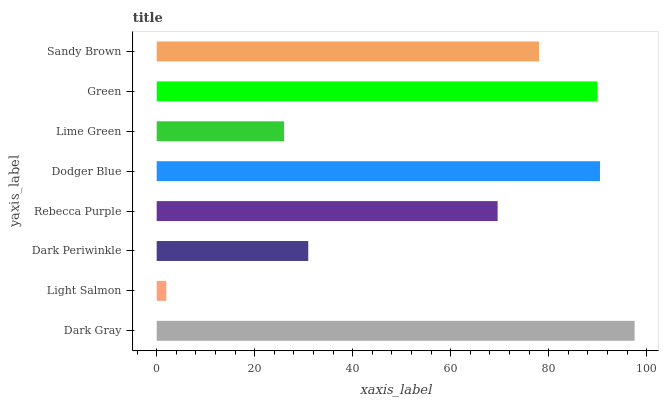Is Light Salmon the minimum?
Answer yes or no. Yes. Is Dark Gray the maximum?
Answer yes or no. Yes. Is Dark Periwinkle the minimum?
Answer yes or no. No. Is Dark Periwinkle the maximum?
Answer yes or no. No. Is Dark Periwinkle greater than Light Salmon?
Answer yes or no. Yes. Is Light Salmon less than Dark Periwinkle?
Answer yes or no. Yes. Is Light Salmon greater than Dark Periwinkle?
Answer yes or no. No. Is Dark Periwinkle less than Light Salmon?
Answer yes or no. No. Is Sandy Brown the high median?
Answer yes or no. Yes. Is Rebecca Purple the low median?
Answer yes or no. Yes. Is Dark Periwinkle the high median?
Answer yes or no. No. Is Sandy Brown the low median?
Answer yes or no. No. 